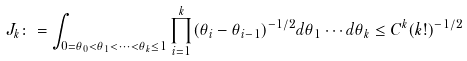<formula> <loc_0><loc_0><loc_500><loc_500>J _ { k } \colon = \int _ { 0 = \theta _ { 0 } < \theta _ { 1 } < \dots < \theta _ { k } \leq 1 } \prod _ { i = 1 } ^ { k } ( \theta _ { i } - \theta _ { i - 1 } ) ^ { - 1 / 2 } d \theta _ { 1 } \cdots d \theta _ { k } \leq C ^ { k } ( k ! ) ^ { - 1 / 2 }</formula> 